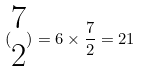<formula> <loc_0><loc_0><loc_500><loc_500>( \begin{matrix} 7 \\ 2 \end{matrix} ) = 6 \times \frac { 7 } { 2 } = 2 1</formula> 